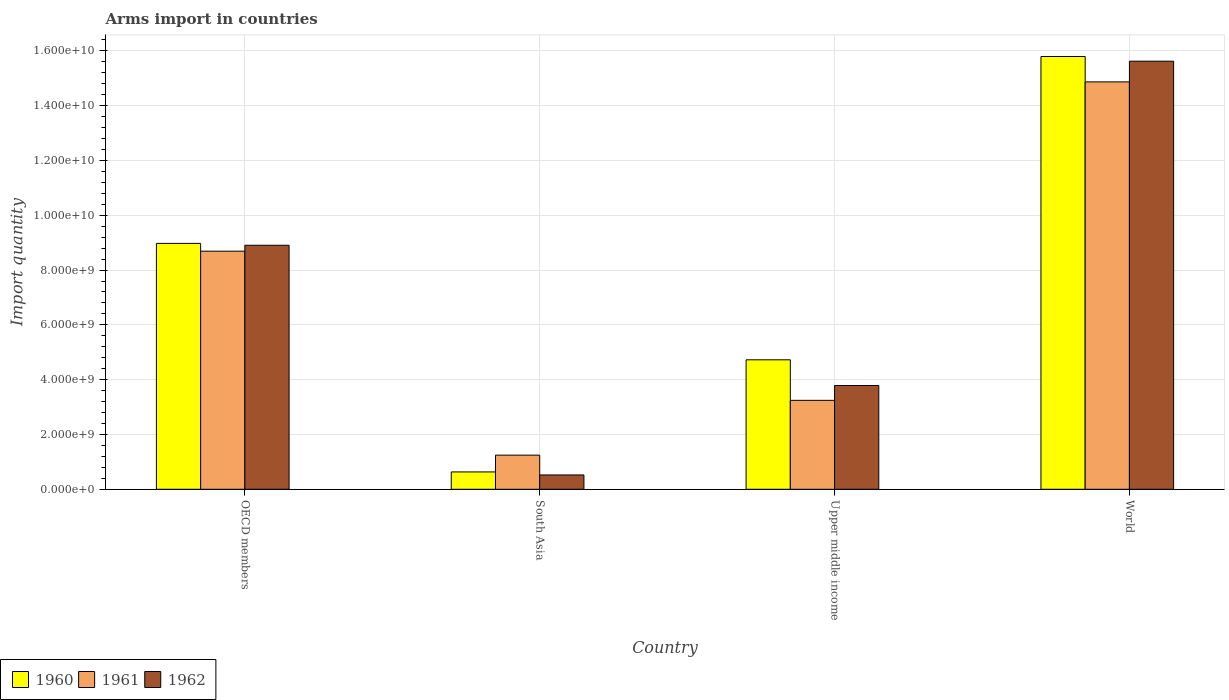Are the number of bars per tick equal to the number of legend labels?
Ensure brevity in your answer.  Yes. Are the number of bars on each tick of the X-axis equal?
Ensure brevity in your answer.  Yes. What is the label of the 3rd group of bars from the left?
Make the answer very short. Upper middle income. What is the total arms import in 1962 in OECD members?
Provide a short and direct response. 8.90e+09. Across all countries, what is the maximum total arms import in 1960?
Provide a succinct answer. 1.58e+1. Across all countries, what is the minimum total arms import in 1960?
Give a very brief answer. 6.33e+08. In which country was the total arms import in 1961 maximum?
Ensure brevity in your answer.  World. In which country was the total arms import in 1961 minimum?
Give a very brief answer. South Asia. What is the total total arms import in 1962 in the graph?
Make the answer very short. 2.88e+1. What is the difference between the total arms import in 1960 in Upper middle income and that in World?
Your response must be concise. -1.11e+1. What is the difference between the total arms import in 1960 in Upper middle income and the total arms import in 1962 in South Asia?
Keep it short and to the point. 4.20e+09. What is the average total arms import in 1960 per country?
Give a very brief answer. 7.53e+09. What is the difference between the total arms import of/in 1962 and total arms import of/in 1961 in OECD members?
Offer a very short reply. 2.16e+08. What is the ratio of the total arms import in 1960 in OECD members to that in World?
Keep it short and to the point. 0.57. Is the difference between the total arms import in 1962 in OECD members and South Asia greater than the difference between the total arms import in 1961 in OECD members and South Asia?
Provide a succinct answer. Yes. What is the difference between the highest and the second highest total arms import in 1960?
Your answer should be very brief. 1.11e+1. What is the difference between the highest and the lowest total arms import in 1961?
Your answer should be compact. 1.36e+1. Is the sum of the total arms import in 1960 in South Asia and Upper middle income greater than the maximum total arms import in 1962 across all countries?
Make the answer very short. No. Are all the bars in the graph horizontal?
Give a very brief answer. No. What is the difference between two consecutive major ticks on the Y-axis?
Offer a very short reply. 2.00e+09. Does the graph contain grids?
Give a very brief answer. Yes. What is the title of the graph?
Make the answer very short. Arms import in countries. Does "1970" appear as one of the legend labels in the graph?
Offer a very short reply. No. What is the label or title of the X-axis?
Ensure brevity in your answer.  Country. What is the label or title of the Y-axis?
Keep it short and to the point. Import quantity. What is the Import quantity in 1960 in OECD members?
Your response must be concise. 8.97e+09. What is the Import quantity in 1961 in OECD members?
Give a very brief answer. 8.69e+09. What is the Import quantity in 1962 in OECD members?
Provide a succinct answer. 8.90e+09. What is the Import quantity in 1960 in South Asia?
Make the answer very short. 6.33e+08. What is the Import quantity of 1961 in South Asia?
Your answer should be compact. 1.25e+09. What is the Import quantity in 1962 in South Asia?
Offer a terse response. 5.23e+08. What is the Import quantity of 1960 in Upper middle income?
Your response must be concise. 4.72e+09. What is the Import quantity in 1961 in Upper middle income?
Your response must be concise. 3.24e+09. What is the Import quantity of 1962 in Upper middle income?
Provide a short and direct response. 3.79e+09. What is the Import quantity of 1960 in World?
Keep it short and to the point. 1.58e+1. What is the Import quantity of 1961 in World?
Keep it short and to the point. 1.49e+1. What is the Import quantity in 1962 in World?
Your answer should be very brief. 1.56e+1. Across all countries, what is the maximum Import quantity in 1960?
Your response must be concise. 1.58e+1. Across all countries, what is the maximum Import quantity of 1961?
Provide a short and direct response. 1.49e+1. Across all countries, what is the maximum Import quantity of 1962?
Ensure brevity in your answer.  1.56e+1. Across all countries, what is the minimum Import quantity in 1960?
Your response must be concise. 6.33e+08. Across all countries, what is the minimum Import quantity in 1961?
Your answer should be very brief. 1.25e+09. Across all countries, what is the minimum Import quantity of 1962?
Provide a succinct answer. 5.23e+08. What is the total Import quantity in 1960 in the graph?
Provide a short and direct response. 3.01e+1. What is the total Import quantity in 1961 in the graph?
Offer a very short reply. 2.80e+1. What is the total Import quantity in 1962 in the graph?
Give a very brief answer. 2.88e+1. What is the difference between the Import quantity of 1960 in OECD members and that in South Asia?
Your response must be concise. 8.34e+09. What is the difference between the Import quantity in 1961 in OECD members and that in South Asia?
Offer a very short reply. 7.44e+09. What is the difference between the Import quantity in 1962 in OECD members and that in South Asia?
Your answer should be compact. 8.38e+09. What is the difference between the Import quantity in 1960 in OECD members and that in Upper middle income?
Your answer should be compact. 4.25e+09. What is the difference between the Import quantity of 1961 in OECD members and that in Upper middle income?
Offer a very short reply. 5.44e+09. What is the difference between the Import quantity in 1962 in OECD members and that in Upper middle income?
Your answer should be compact. 5.12e+09. What is the difference between the Import quantity in 1960 in OECD members and that in World?
Your answer should be very brief. -6.82e+09. What is the difference between the Import quantity in 1961 in OECD members and that in World?
Offer a terse response. -6.18e+09. What is the difference between the Import quantity of 1962 in OECD members and that in World?
Offer a very short reply. -6.72e+09. What is the difference between the Import quantity in 1960 in South Asia and that in Upper middle income?
Offer a very short reply. -4.09e+09. What is the difference between the Import quantity in 1961 in South Asia and that in Upper middle income?
Ensure brevity in your answer.  -2.00e+09. What is the difference between the Import quantity in 1962 in South Asia and that in Upper middle income?
Your response must be concise. -3.26e+09. What is the difference between the Import quantity in 1960 in South Asia and that in World?
Offer a very short reply. -1.52e+1. What is the difference between the Import quantity in 1961 in South Asia and that in World?
Make the answer very short. -1.36e+1. What is the difference between the Import quantity in 1962 in South Asia and that in World?
Offer a terse response. -1.51e+1. What is the difference between the Import quantity of 1960 in Upper middle income and that in World?
Offer a terse response. -1.11e+1. What is the difference between the Import quantity of 1961 in Upper middle income and that in World?
Offer a very short reply. -1.16e+1. What is the difference between the Import quantity in 1962 in Upper middle income and that in World?
Make the answer very short. -1.18e+1. What is the difference between the Import quantity of 1960 in OECD members and the Import quantity of 1961 in South Asia?
Give a very brief answer. 7.73e+09. What is the difference between the Import quantity in 1960 in OECD members and the Import quantity in 1962 in South Asia?
Give a very brief answer. 8.45e+09. What is the difference between the Import quantity of 1961 in OECD members and the Import quantity of 1962 in South Asia?
Make the answer very short. 8.17e+09. What is the difference between the Import quantity of 1960 in OECD members and the Import quantity of 1961 in Upper middle income?
Give a very brief answer. 5.73e+09. What is the difference between the Import quantity of 1960 in OECD members and the Import quantity of 1962 in Upper middle income?
Ensure brevity in your answer.  5.19e+09. What is the difference between the Import quantity in 1961 in OECD members and the Import quantity in 1962 in Upper middle income?
Give a very brief answer. 4.90e+09. What is the difference between the Import quantity in 1960 in OECD members and the Import quantity in 1961 in World?
Provide a short and direct response. -5.89e+09. What is the difference between the Import quantity in 1960 in OECD members and the Import quantity in 1962 in World?
Give a very brief answer. -6.65e+09. What is the difference between the Import quantity of 1961 in OECD members and the Import quantity of 1962 in World?
Provide a succinct answer. -6.93e+09. What is the difference between the Import quantity of 1960 in South Asia and the Import quantity of 1961 in Upper middle income?
Give a very brief answer. -2.61e+09. What is the difference between the Import quantity in 1960 in South Asia and the Import quantity in 1962 in Upper middle income?
Your response must be concise. -3.15e+09. What is the difference between the Import quantity of 1961 in South Asia and the Import quantity of 1962 in Upper middle income?
Keep it short and to the point. -2.54e+09. What is the difference between the Import quantity in 1960 in South Asia and the Import quantity in 1961 in World?
Your answer should be very brief. -1.42e+1. What is the difference between the Import quantity in 1960 in South Asia and the Import quantity in 1962 in World?
Your response must be concise. -1.50e+1. What is the difference between the Import quantity in 1961 in South Asia and the Import quantity in 1962 in World?
Your answer should be very brief. -1.44e+1. What is the difference between the Import quantity in 1960 in Upper middle income and the Import quantity in 1961 in World?
Offer a very short reply. -1.01e+1. What is the difference between the Import quantity in 1960 in Upper middle income and the Import quantity in 1962 in World?
Keep it short and to the point. -1.09e+1. What is the difference between the Import quantity in 1961 in Upper middle income and the Import quantity in 1962 in World?
Make the answer very short. -1.24e+1. What is the average Import quantity of 1960 per country?
Your response must be concise. 7.53e+09. What is the average Import quantity in 1961 per country?
Make the answer very short. 7.01e+09. What is the average Import quantity of 1962 per country?
Provide a succinct answer. 7.21e+09. What is the difference between the Import quantity in 1960 and Import quantity in 1961 in OECD members?
Keep it short and to the point. 2.84e+08. What is the difference between the Import quantity in 1960 and Import quantity in 1962 in OECD members?
Keep it short and to the point. 6.80e+07. What is the difference between the Import quantity of 1961 and Import quantity of 1962 in OECD members?
Give a very brief answer. -2.16e+08. What is the difference between the Import quantity in 1960 and Import quantity in 1961 in South Asia?
Give a very brief answer. -6.13e+08. What is the difference between the Import quantity of 1960 and Import quantity of 1962 in South Asia?
Keep it short and to the point. 1.10e+08. What is the difference between the Import quantity in 1961 and Import quantity in 1962 in South Asia?
Offer a terse response. 7.23e+08. What is the difference between the Import quantity in 1960 and Import quantity in 1961 in Upper middle income?
Your answer should be very brief. 1.48e+09. What is the difference between the Import quantity in 1960 and Import quantity in 1962 in Upper middle income?
Provide a short and direct response. 9.39e+08. What is the difference between the Import quantity of 1961 and Import quantity of 1962 in Upper middle income?
Keep it short and to the point. -5.41e+08. What is the difference between the Import quantity in 1960 and Import quantity in 1961 in World?
Provide a succinct answer. 9.26e+08. What is the difference between the Import quantity in 1960 and Import quantity in 1962 in World?
Offer a very short reply. 1.71e+08. What is the difference between the Import quantity of 1961 and Import quantity of 1962 in World?
Your response must be concise. -7.55e+08. What is the ratio of the Import quantity of 1960 in OECD members to that in South Asia?
Ensure brevity in your answer.  14.18. What is the ratio of the Import quantity of 1961 in OECD members to that in South Asia?
Keep it short and to the point. 6.97. What is the ratio of the Import quantity of 1962 in OECD members to that in South Asia?
Ensure brevity in your answer.  17.03. What is the ratio of the Import quantity in 1960 in OECD members to that in Upper middle income?
Your response must be concise. 1.9. What is the ratio of the Import quantity in 1961 in OECD members to that in Upper middle income?
Offer a terse response. 2.68. What is the ratio of the Import quantity of 1962 in OECD members to that in Upper middle income?
Offer a very short reply. 2.35. What is the ratio of the Import quantity of 1960 in OECD members to that in World?
Your response must be concise. 0.57. What is the ratio of the Import quantity in 1961 in OECD members to that in World?
Offer a very short reply. 0.58. What is the ratio of the Import quantity of 1962 in OECD members to that in World?
Your answer should be compact. 0.57. What is the ratio of the Import quantity in 1960 in South Asia to that in Upper middle income?
Your answer should be compact. 0.13. What is the ratio of the Import quantity of 1961 in South Asia to that in Upper middle income?
Your answer should be compact. 0.38. What is the ratio of the Import quantity in 1962 in South Asia to that in Upper middle income?
Provide a short and direct response. 0.14. What is the ratio of the Import quantity in 1960 in South Asia to that in World?
Provide a succinct answer. 0.04. What is the ratio of the Import quantity in 1961 in South Asia to that in World?
Keep it short and to the point. 0.08. What is the ratio of the Import quantity in 1962 in South Asia to that in World?
Offer a very short reply. 0.03. What is the ratio of the Import quantity in 1960 in Upper middle income to that in World?
Offer a terse response. 0.3. What is the ratio of the Import quantity in 1961 in Upper middle income to that in World?
Make the answer very short. 0.22. What is the ratio of the Import quantity of 1962 in Upper middle income to that in World?
Keep it short and to the point. 0.24. What is the difference between the highest and the second highest Import quantity of 1960?
Your response must be concise. 6.82e+09. What is the difference between the highest and the second highest Import quantity of 1961?
Provide a short and direct response. 6.18e+09. What is the difference between the highest and the second highest Import quantity in 1962?
Offer a terse response. 6.72e+09. What is the difference between the highest and the lowest Import quantity of 1960?
Your answer should be compact. 1.52e+1. What is the difference between the highest and the lowest Import quantity of 1961?
Give a very brief answer. 1.36e+1. What is the difference between the highest and the lowest Import quantity in 1962?
Keep it short and to the point. 1.51e+1. 